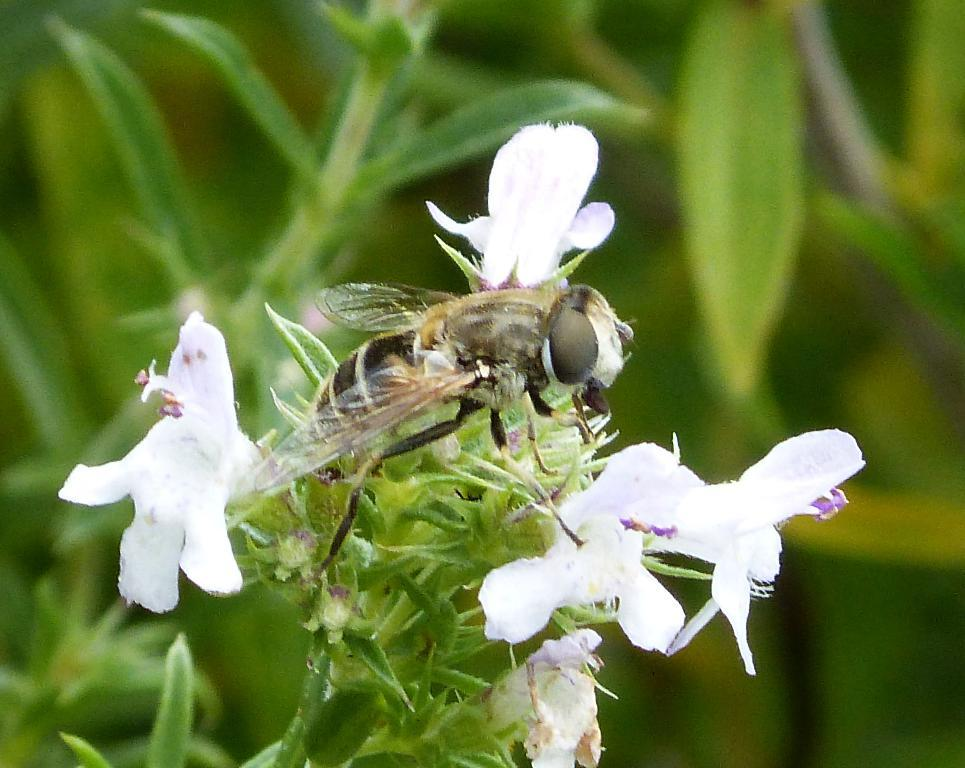What type of plant is visible in the image? There is a plant with white flowers in the image. Is there any other living organism on the plant? Yes, there is an insect on the plant. Can you describe the background of the image? The background of the image is blurred. What type of offer is the plant making to the insect in the image? There is no indication in the image that the plant is making any offer to the insect. 